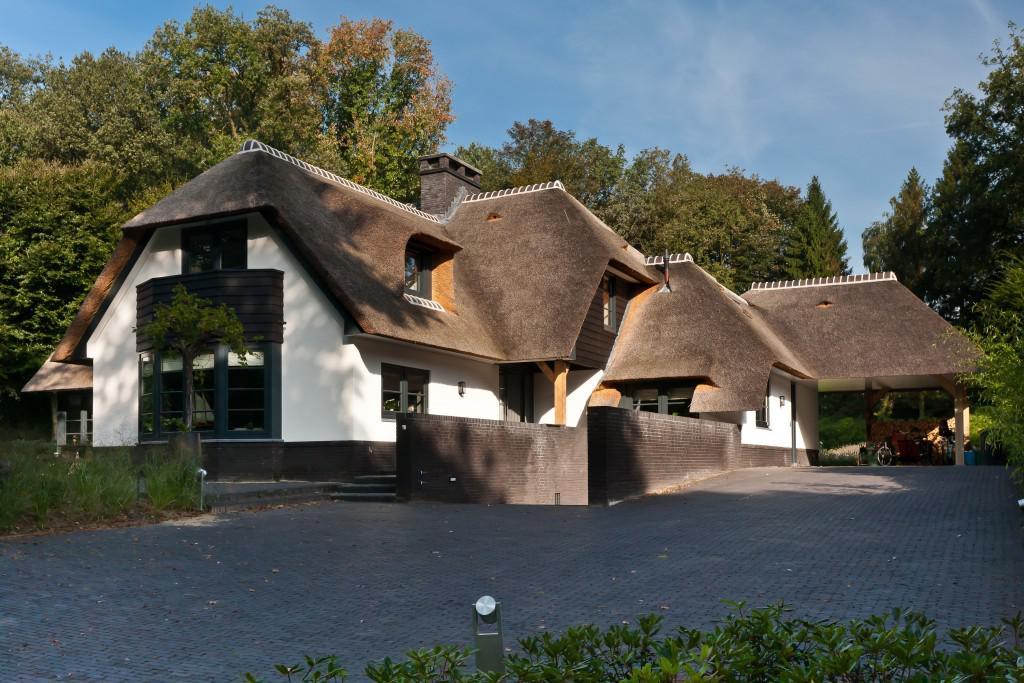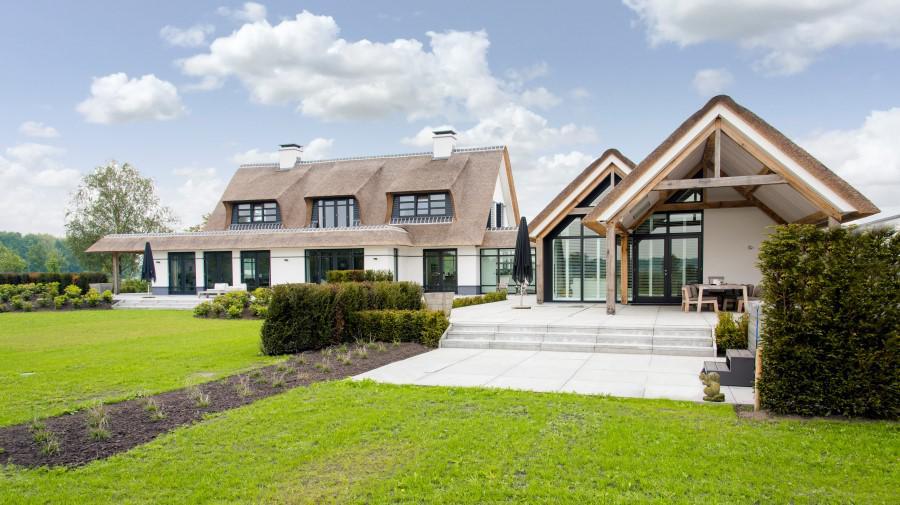The first image is the image on the left, the second image is the image on the right. Evaluate the accuracy of this statement regarding the images: "In at least one image  there is a white home with three windows and at least three triangle roof peaks.". Is it true? Answer yes or no. Yes. 